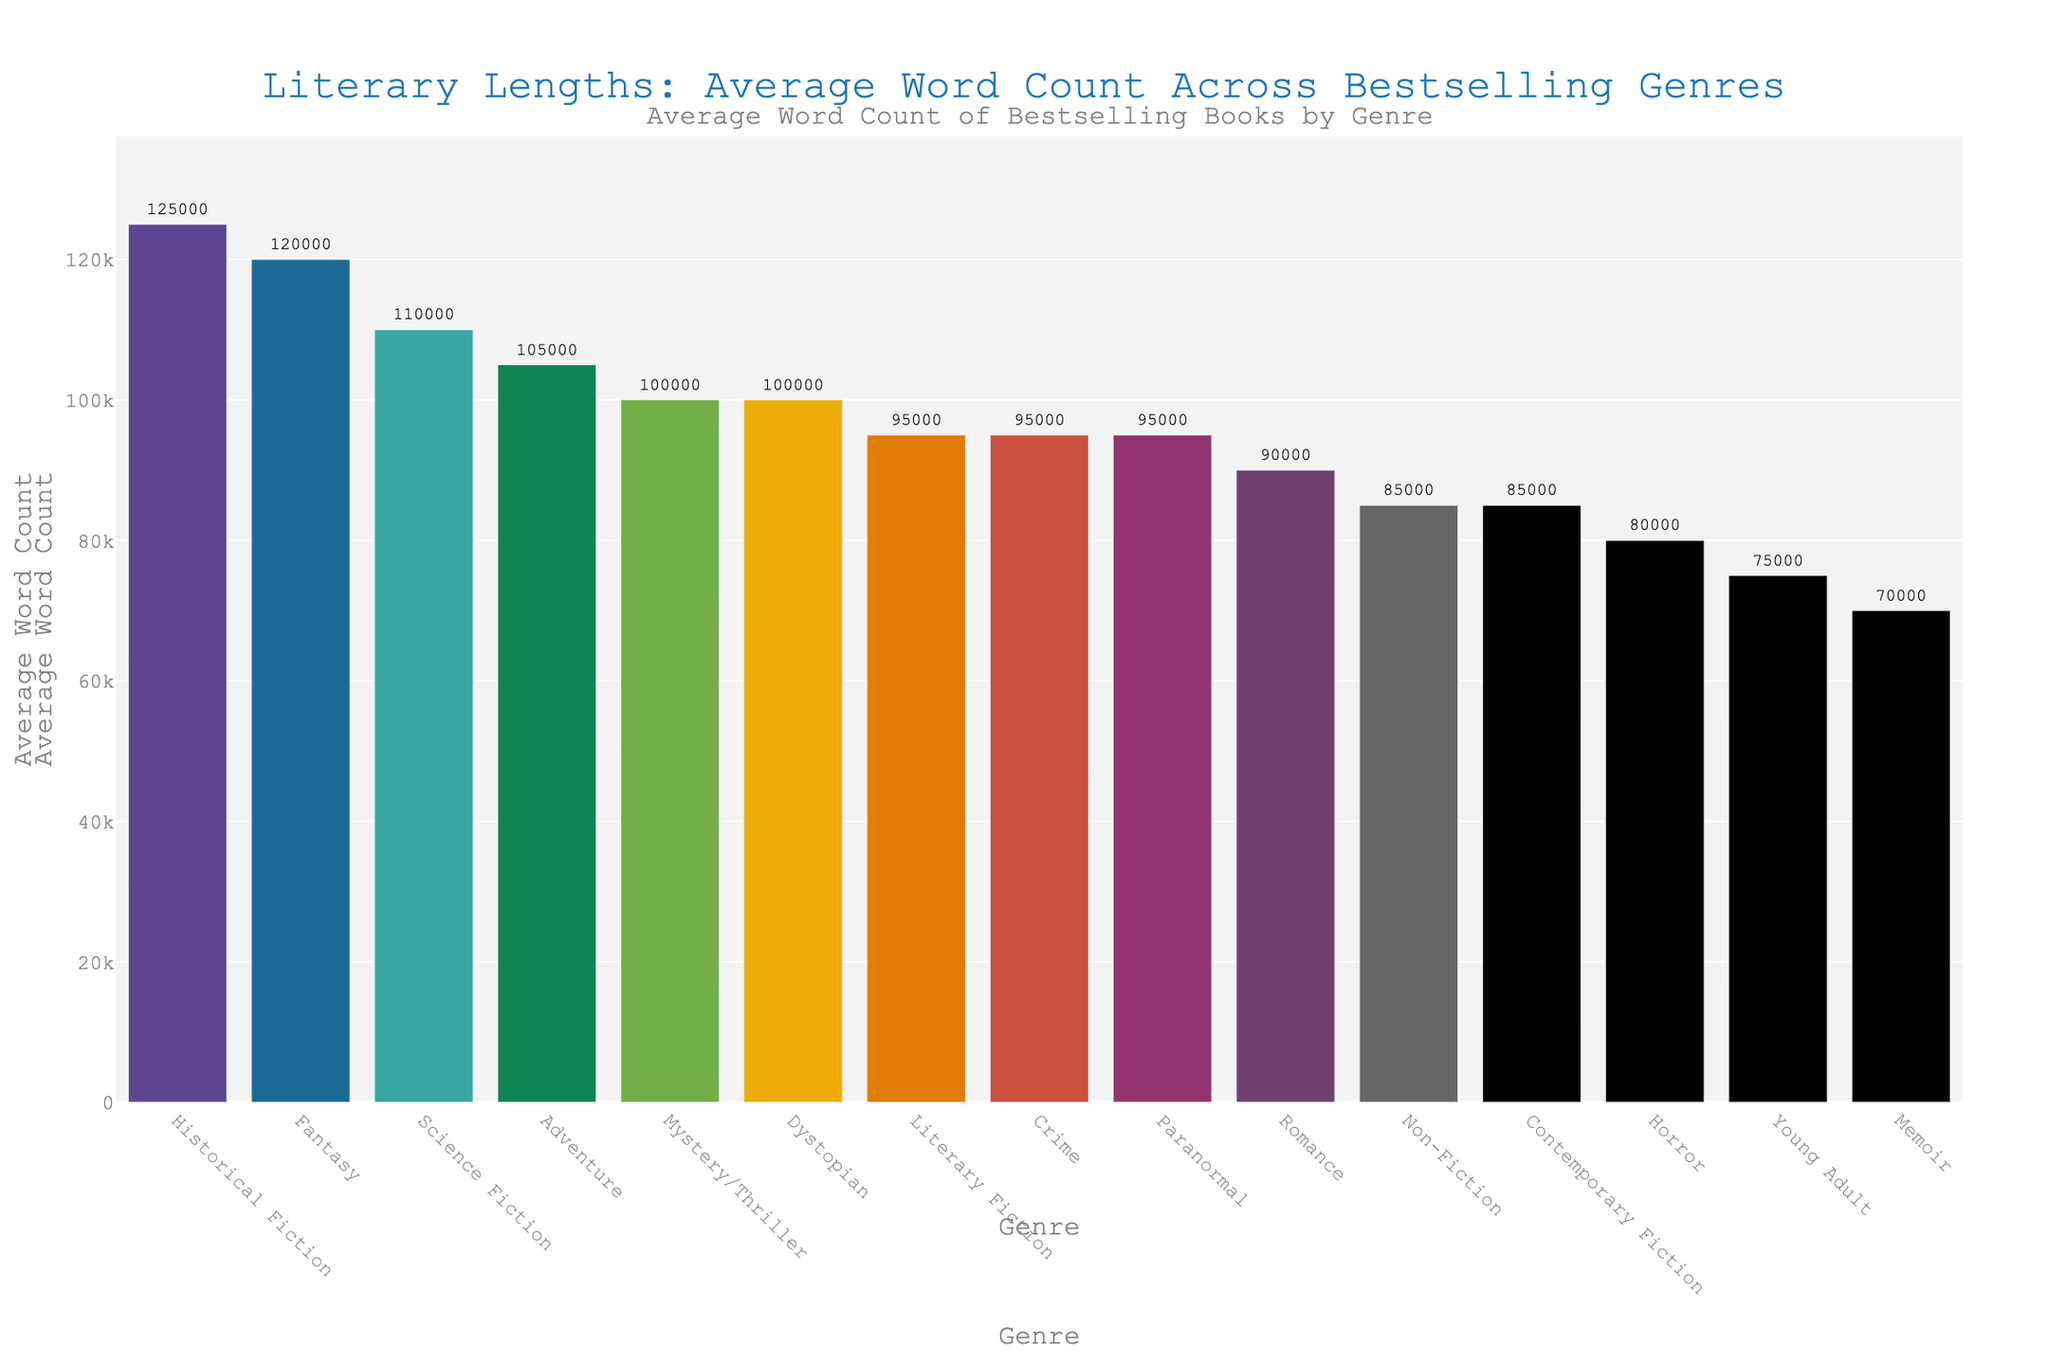What genre has the highest average word count? The highest bar in the chart represents "Historical Fiction" with an average word count. By looking at the labels, it shows 125,000.
Answer: Historical Fiction Which genre has the lowest average word count? The shortest bar in the chart represents "Memoir". By examining the label, it shows an average word count of 70,000.
Answer: Memoir How many genres have an average word count of at least 100,000? By counting the number of bars with an average word count of 100,000 or higher, we see that "Mystery/Thriller," "Science Fiction," "Fantasy," "Historical Fiction," and "Adventure" meet this criterion.
Answer: 5 What's the difference in average word count between Romance and Science Fiction genres? The bar for "Romance" shows an average word count of 90,000, and "Science Fiction" shows 110,000. The difference between them is 110,000 - 90,000.
Answer: 20,000 Which genre has a higher average word count: Horror or Young Adult? The bar for "Horror" shows an average word count of 80,000, while "Young Adult" shows 75,000. Comparing the heights of the bars, "Horror" has a higher average word count.
Answer: Horror What is the combined average word count for Memoir and Non-Fiction genres? The average word count for "Memoir" is 70,000 and for "Non-Fiction" is 85,000. Adding these gives 70,000 + 85,000.
Answer: 155,000 Which three genres have average word counts closest to 95,000? By examining the bars, the genres with average word counts near 95,000 are "Literary Fiction," "Crime," and "Paranormal," each showing 95,000.
Answer: Literary Fiction, Crime, Paranormal Is the average word count of Contemporary Fiction higher than that of Non-Fiction? The bar for "Contemporary Fiction" shows an average word count of 85,000, which is the same as "Non-Fiction."
Answer: No What is the average word count of genres with "Fiction" in their name? "Literary Fiction" has 95,000, "Historical Fiction" has 125,000, and "Contemporary Fiction" has 85,000. Summing these and then dividing by 3: (95,000 + 125,000 + 85,000)/3.
Answer: 101,667 